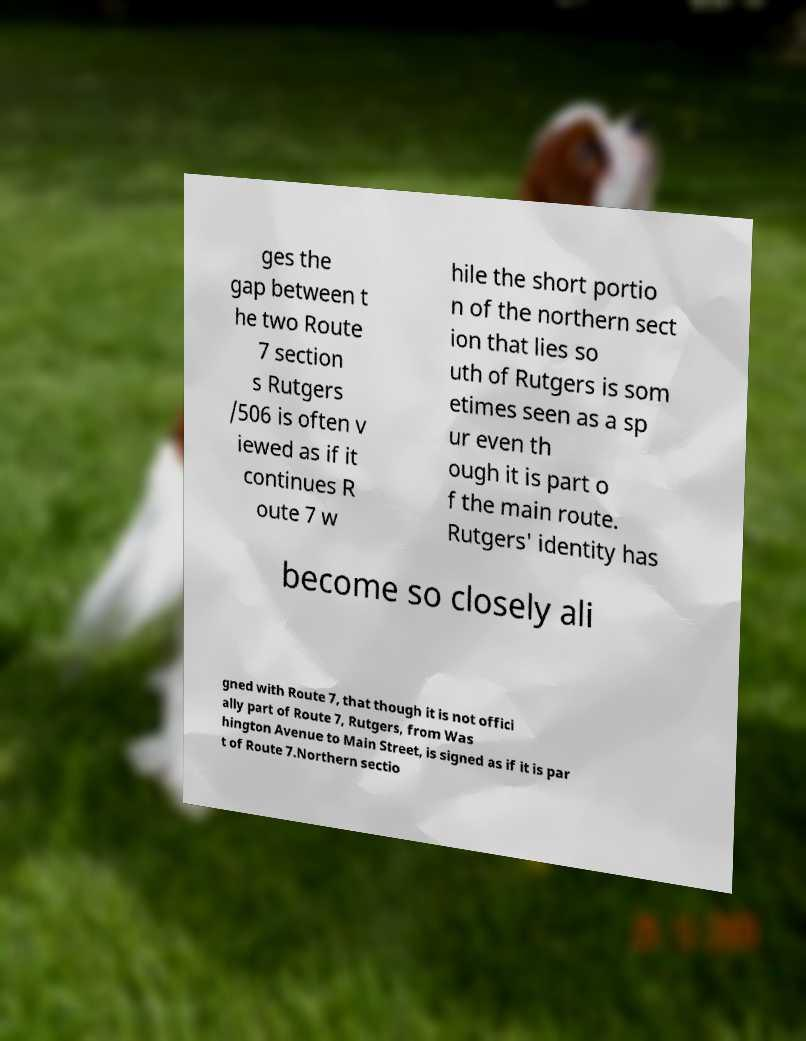Can you accurately transcribe the text from the provided image for me? ges the gap between t he two Route 7 section s Rutgers /506 is often v iewed as if it continues R oute 7 w hile the short portio n of the northern sect ion that lies so uth of Rutgers is som etimes seen as a sp ur even th ough it is part o f the main route. Rutgers' identity has become so closely ali gned with Route 7, that though it is not offici ally part of Route 7, Rutgers, from Was hington Avenue to Main Street, is signed as if it is par t of Route 7.Northern sectio 